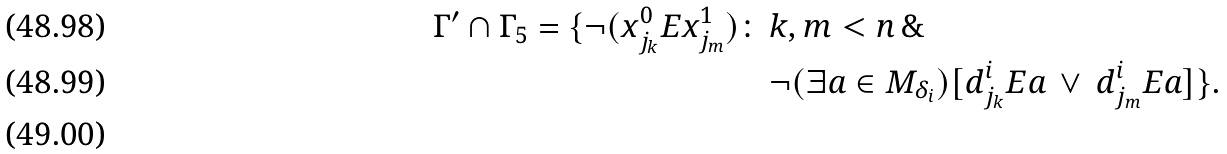<formula> <loc_0><loc_0><loc_500><loc_500>\Gamma ^ { \prime } \cap \Gamma _ { 5 } = \{ \neg ( x ^ { 0 } _ { j _ { k } } E x ^ { 1 } _ { j _ { m } } ) \colon \, & k , m < n \, \& \, \\ & \neg ( \exists a \in M _ { \delta _ { i } } ) [ d ^ { i } _ { j _ { k } } E a \, \vee \, d ^ { i } _ { j _ { m } } E a ] \} . \\</formula> 